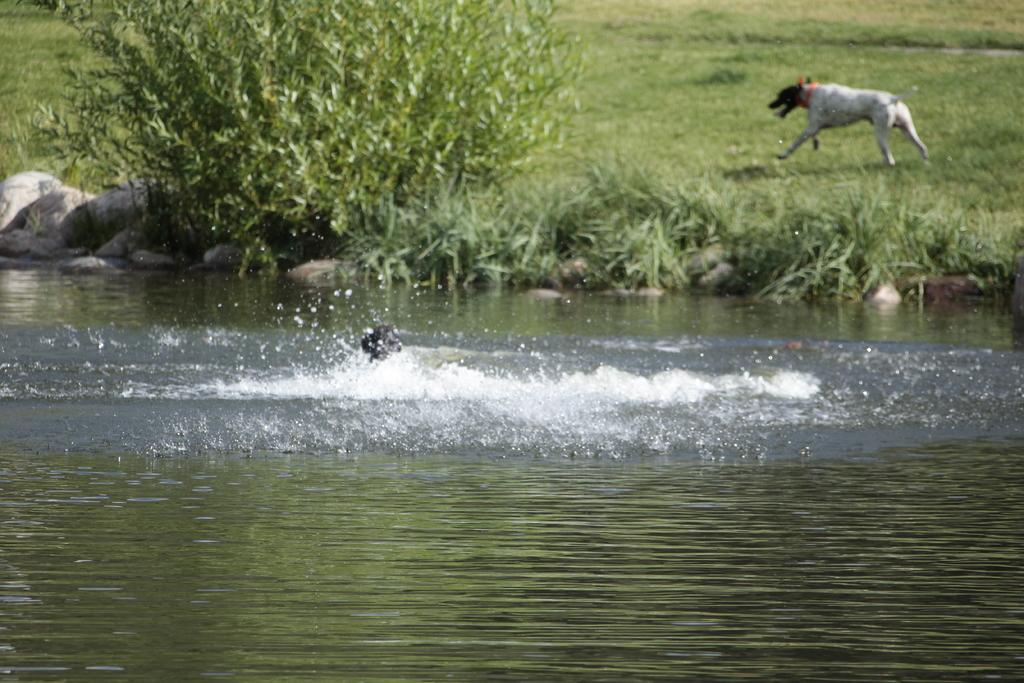What is in the foreground of the image? There is water in the foreground of the image. What animal is in the water? A dog is present in the water. What can be seen in the background of the image? There is a plant, stones, and grass in the background of the image. What is the dog doing in the background of the image? There is a dog running on the grass in the background of the image. How many boys are playing with the ball in the park in the image? There is no park, ball, or boys present in the image. 